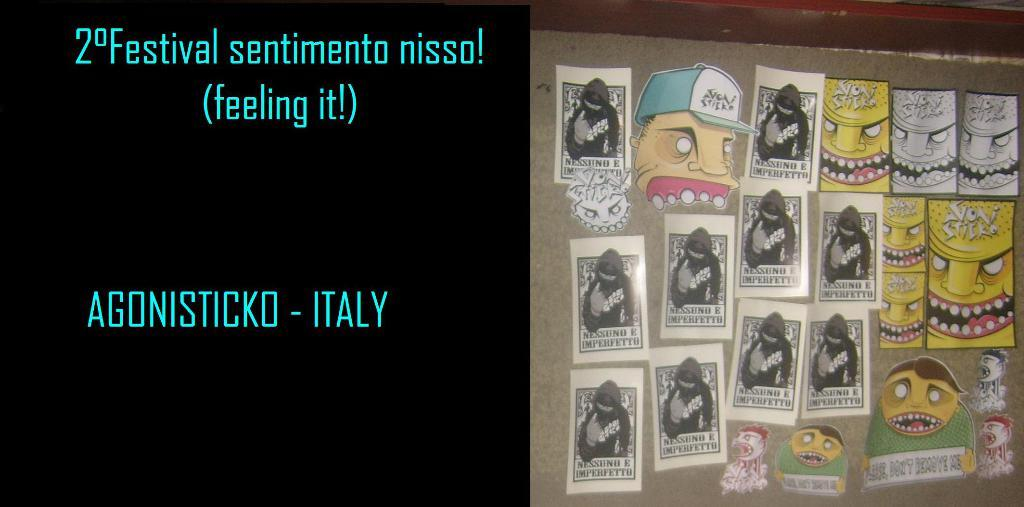<image>
Write a terse but informative summary of the picture. Board that has pictures of cartoon faces on it and the country ITALY on the left. 